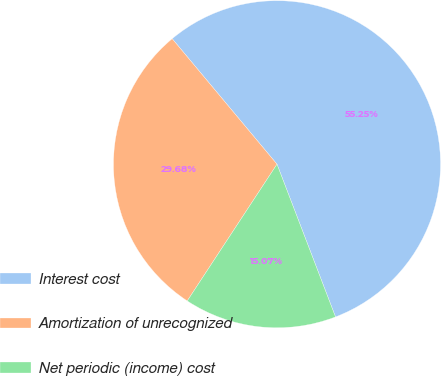Convert chart. <chart><loc_0><loc_0><loc_500><loc_500><pie_chart><fcel>Interest cost<fcel>Amortization of unrecognized<fcel>Net periodic (income) cost<nl><fcel>55.25%<fcel>29.68%<fcel>15.07%<nl></chart> 